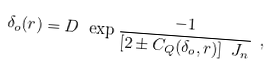Convert formula to latex. <formula><loc_0><loc_0><loc_500><loc_500>\delta _ { o } ( r ) = D \ \exp { \frac { - 1 } { [ 2 \pm C _ { Q } ( \delta _ { o } , r ) ] \ J _ { n } } } \ ,</formula> 